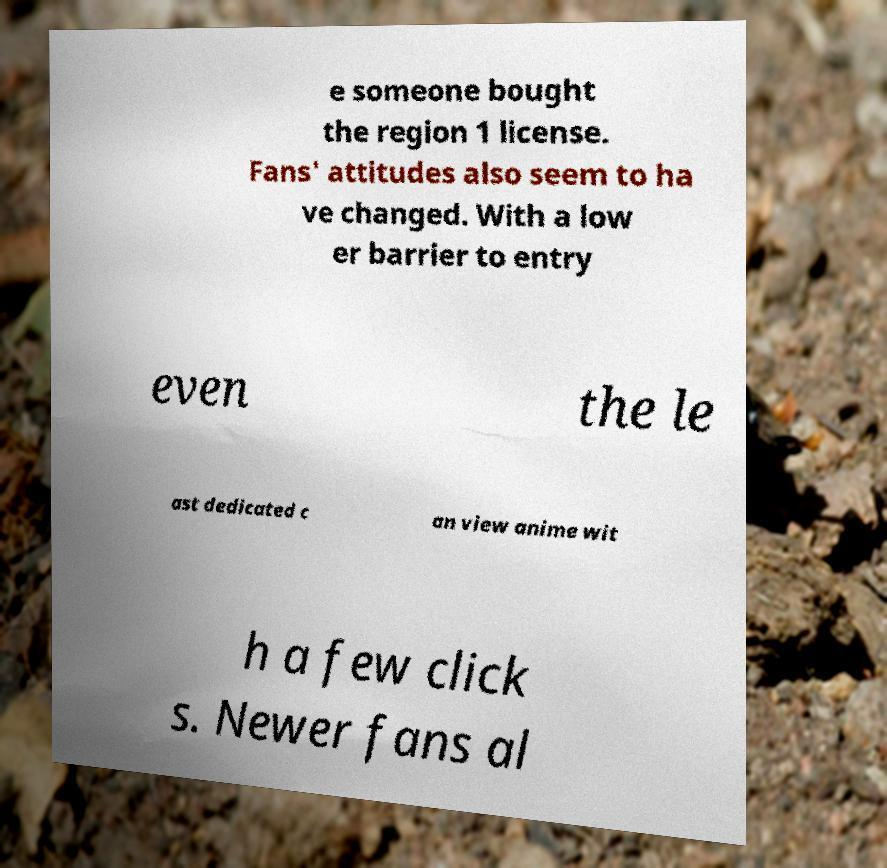I need the written content from this picture converted into text. Can you do that? e someone bought the region 1 license. Fans' attitudes also seem to ha ve changed. With a low er barrier to entry even the le ast dedicated c an view anime wit h a few click s. Newer fans al 